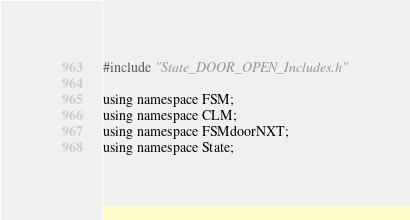Convert code to text. <code><loc_0><loc_0><loc_500><loc_500><_ObjectiveC_>
#include "State_DOOR_OPEN_Includes.h"

using namespace FSM;
using namespace CLM;
using namespace FSMdoorNXT;
using namespace State;
</code> 